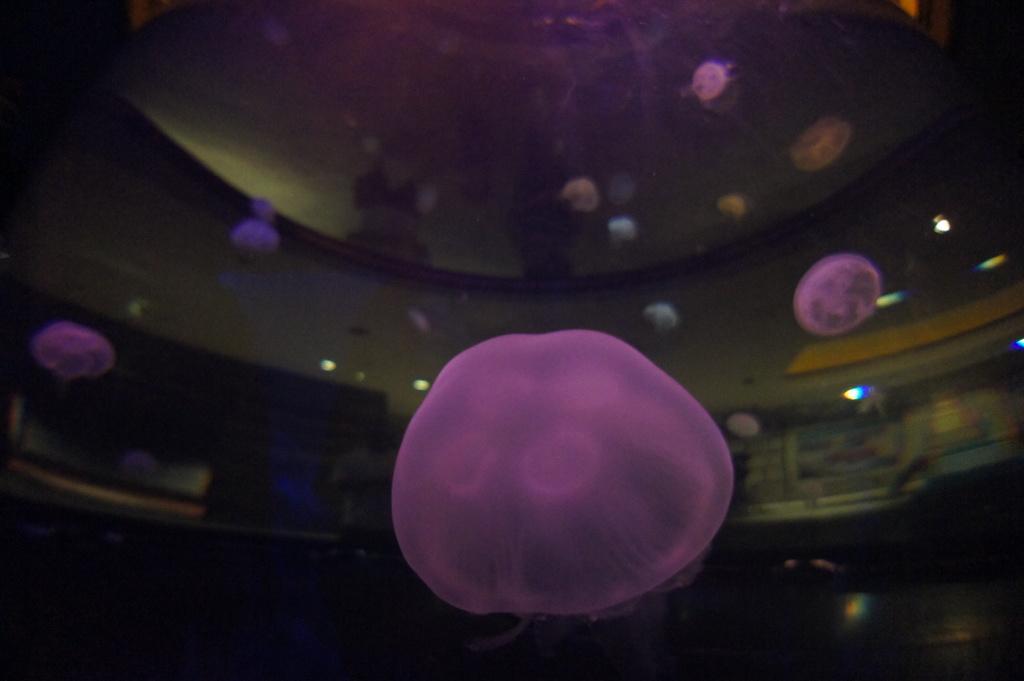How would you summarize this image in a sentence or two? In this image I see few objects which are of violet, white and brown in color and I see the lights and in the background it is a bit dark. 